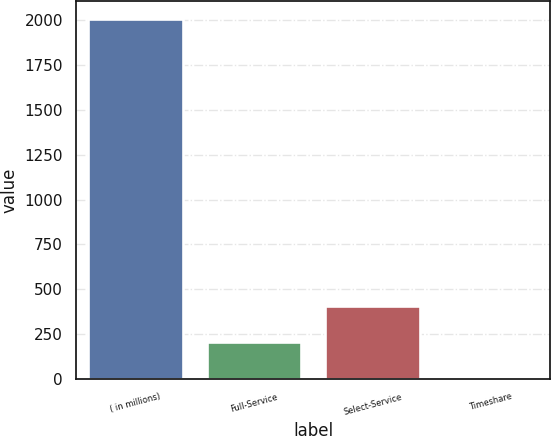Convert chart to OTSL. <chart><loc_0><loc_0><loc_500><loc_500><bar_chart><fcel>( in millions)<fcel>Full-Service<fcel>Select-Service<fcel>Timeshare<nl><fcel>2004<fcel>206.7<fcel>406.4<fcel>7<nl></chart> 